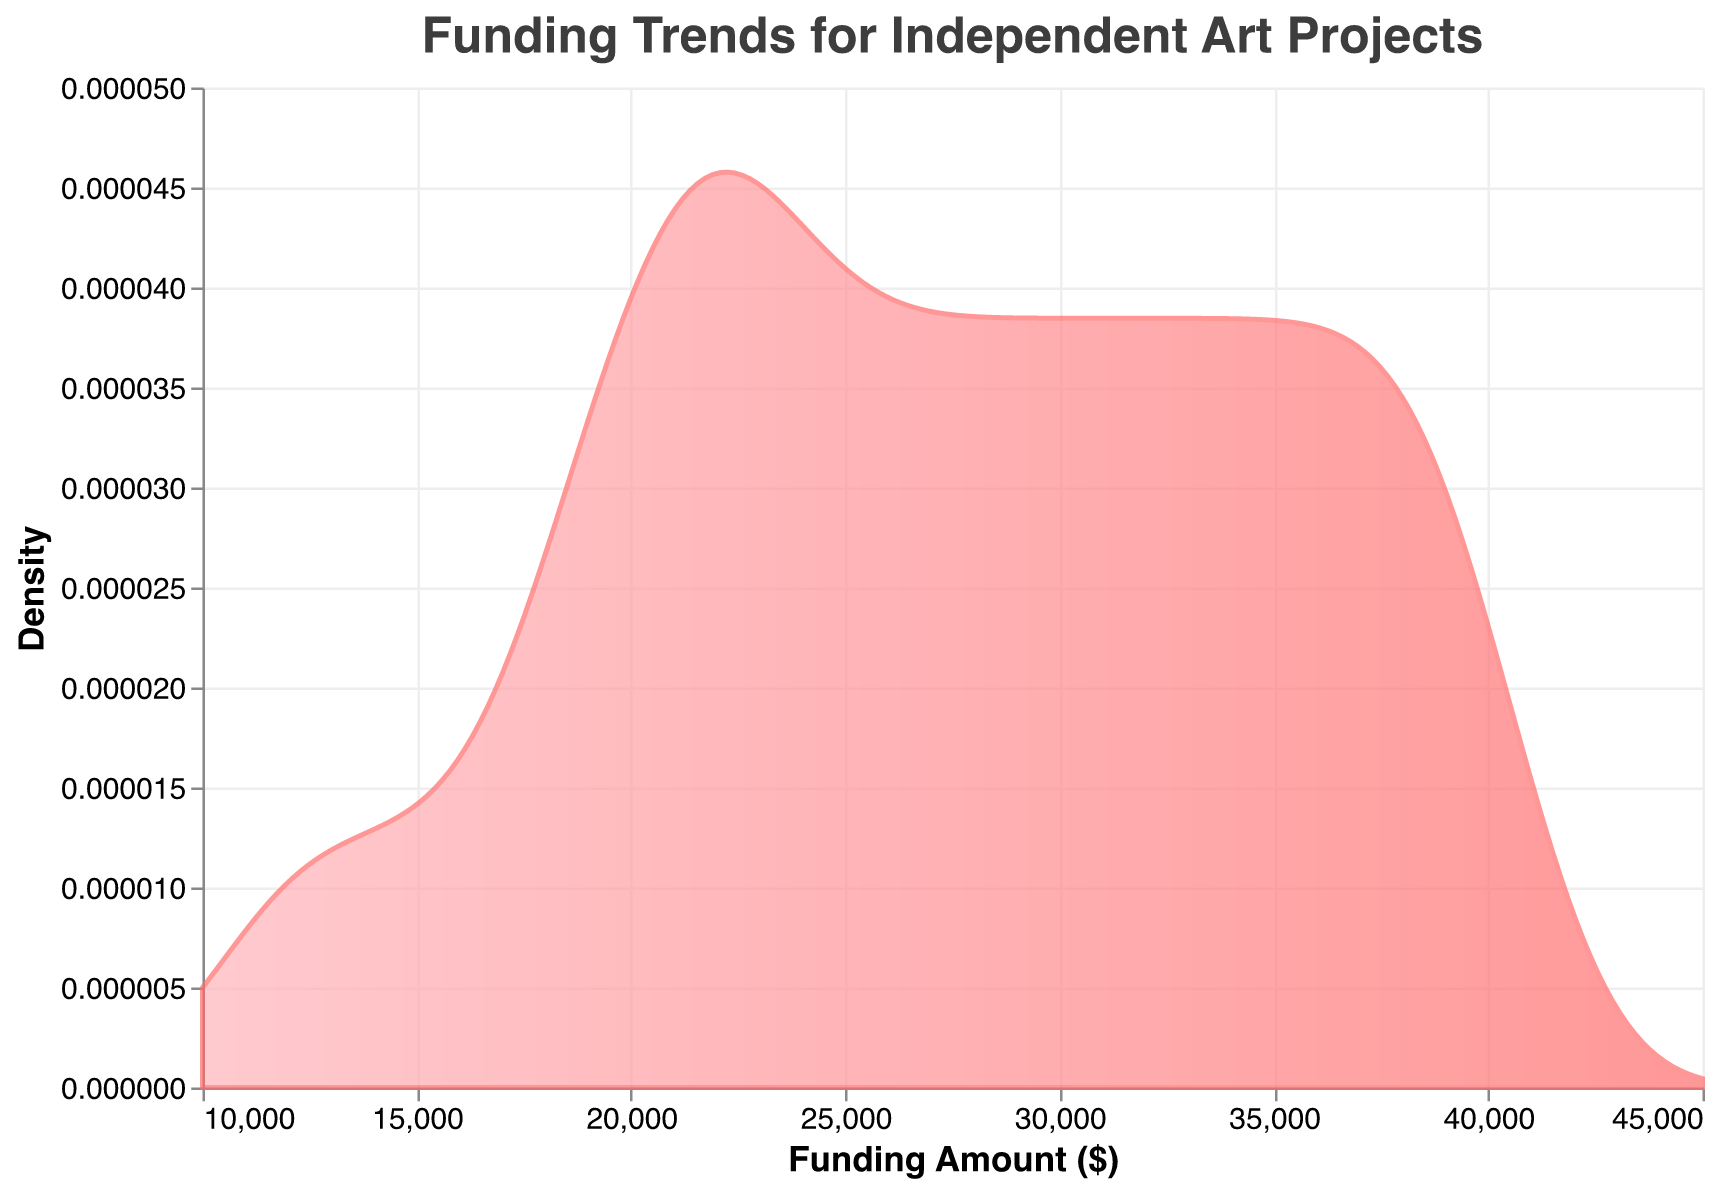What's the title of the figure? The title of the figure is usually placed at the top and is intended to give a clear overview of what the data is about. In this case, the title text is provided in the code.
Answer: Funding Trends for Independent Art Projects What does the x-axis represent? The x-axis typically shows one dimension of the data being plotted. Here, it is labeled as "Funding Amount ($)", indicating that the x-axis represents the funding amounts in dollars.
Answer: Funding Amount ($) What is the range of funding amounts shown on the x-axis? The range of funding amounts on the x-axis can be observed from the axis labels. Here, the range is from the lowest visible value to the highest visible value.
Answer: $10,000 to $45,000 Which color gradient is used in the density plot? The color gradient involves a linear blend of two colors. The colors provided are "#FFB3BA" and "#FF6B6B", which describe a transition from a light pink to a more vivid pink.
Answer: Light pink to vivid pink Is the density higher for funding amounts around $15,000 or $40,000? To answer this, we look at the y-axis values for the density at those specific funding amounts. Higher density is indicated by a higher y-axis value.
Answer: $15,000 Around which funding amount does the density peak? The peak density corresponds to the highest point on the y-axis in the plot. By identifying this peak, we can determine the funding amount at which it occurs.
Answer: $20,000 What's the main trend observed in the density plot? Observing the overall shape and behavior of the plot gives insight into how the density of funding amounts changes.
Answer: Most funding amounts hover around $20,000 and $30,000, with less funding under or over these amounts Do funding amounts show a wider spread in the lower or upper range? To compare the spread, we observe the width of the plot at different ranges. A wider plot implies a wider spread.
Answer: Upper range How many funding bands show a density close to zero? Identifying regions where the plot is nearly flat or touching the x-axis implies density close to zero. Count these regions.
Answer: Two bands What is the density value at a funding amount of $30,000? To accurately find this value, locate $30,000 on the x-axis and read the corresponding y-axis value.
Answer: Approximately 0.00002 